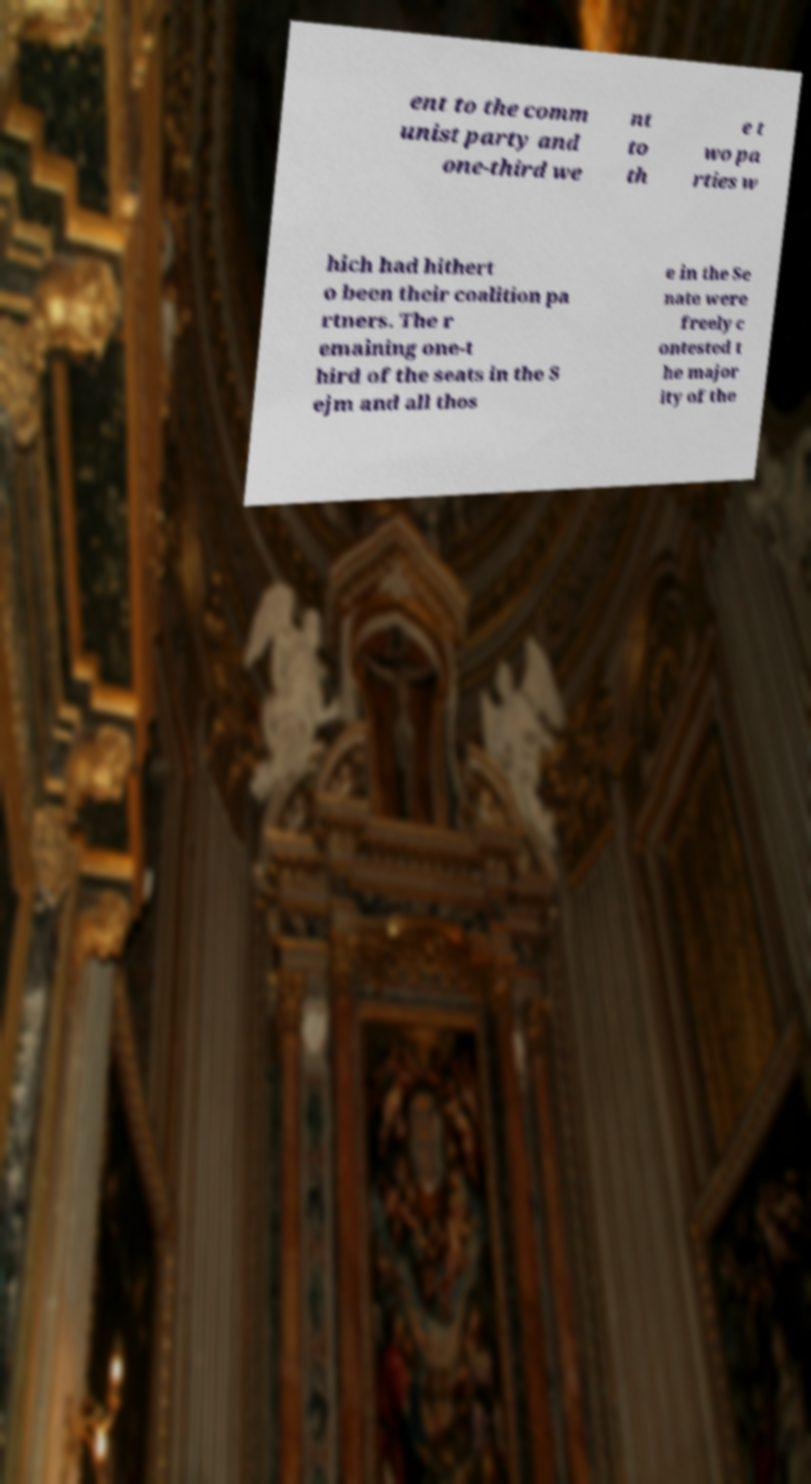For documentation purposes, I need the text within this image transcribed. Could you provide that? ent to the comm unist party and one-third we nt to th e t wo pa rties w hich had hithert o been their coalition pa rtners. The r emaining one-t hird of the seats in the S ejm and all thos e in the Se nate were freely c ontested t he major ity of the 